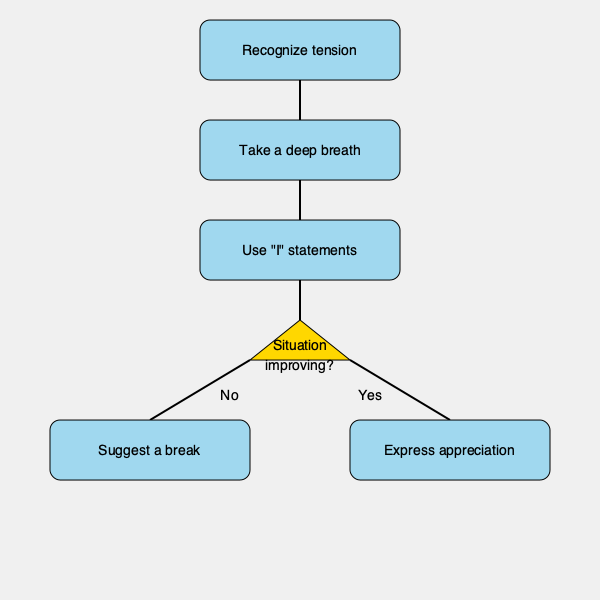In the flowchart for de-escalating a tense situation, what is the crucial step immediately following the recognition of tension? The flowchart illustrates a step-by-step process for de-escalating a tense situation, which aligns with the persona of a pacifist spouse who encourages nonviolent approaches to conflict resolution. Let's analyze the steps:

1. The process begins with "Recognize tension," which is the initial step in addressing any conflict.

2. Immediately following this recognition, the flowchart shows "Take a deep breath" as the next step. This is a crucial action because:
   a) It provides a moment of pause, preventing immediate reactive responses.
   b) Deep breathing helps to calm the nervous system, reducing stress and promoting clearer thinking.
   c) It creates a brief space for reflection before proceeding with communication.

3. The subsequent step is "Use 'I' statements," which is an effective communication technique for expressing feelings without blame.

4. The flowchart then leads to a decision point, asking if the situation is improving.

5. Based on the answer to this question, the chart branches into two possibilities:
   - If no improvement, it suggests taking a break.
   - If improvement is observed, it recommends expressing appreciation.

The question specifically asks about the step immediately following the recognition of tension. According to the flowchart, this critical step is taking a deep breath, which sets the foundation for a calm and constructive approach to resolving the conflict.
Answer: Take a deep breath 